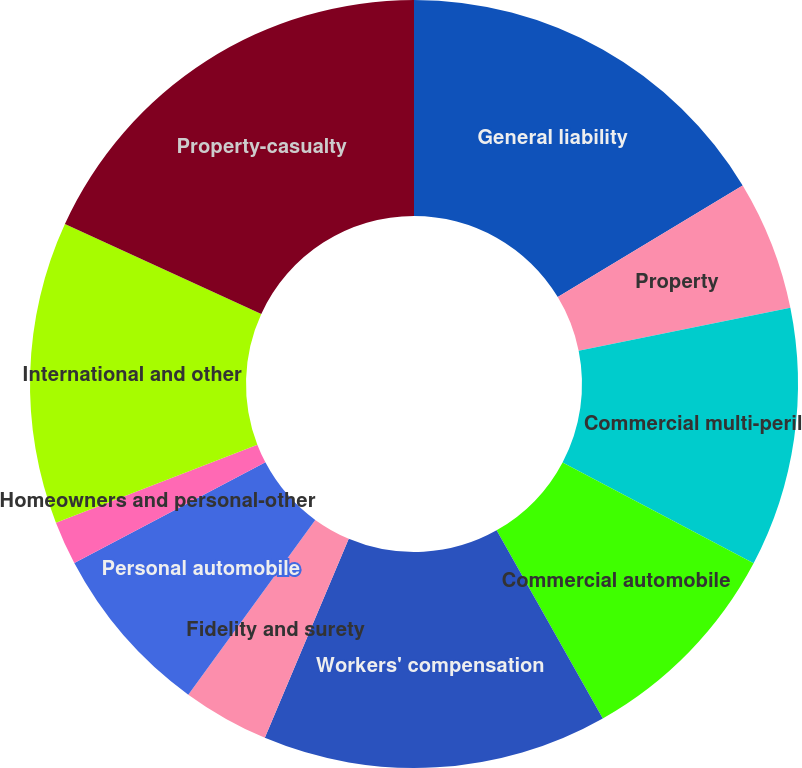Convert chart. <chart><loc_0><loc_0><loc_500><loc_500><pie_chart><fcel>General liability<fcel>Property<fcel>Commercial multi-peril<fcel>Commercial automobile<fcel>Workers' compensation<fcel>Fidelity and surety<fcel>Personal automobile<fcel>Homeowners and personal-other<fcel>International and other<fcel>Property-casualty<nl><fcel>16.35%<fcel>5.47%<fcel>10.91%<fcel>9.09%<fcel>14.53%<fcel>3.65%<fcel>7.28%<fcel>1.84%<fcel>12.72%<fcel>18.16%<nl></chart> 